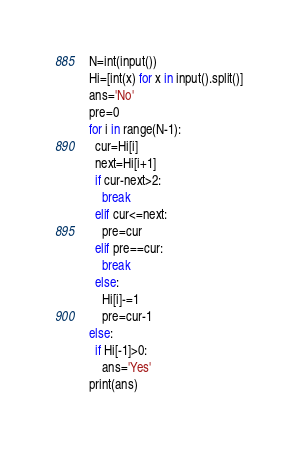Convert code to text. <code><loc_0><loc_0><loc_500><loc_500><_Python_>N=int(input())
Hi=[int(x) for x in input().split()]
ans='No'
pre=0
for i in range(N-1):
  cur=Hi[i]
  next=Hi[i+1]
  if cur-next>2:
    break
  elif cur<=next:
    pre=cur
  elif pre==cur:
    break
  else:
    Hi[i]-=1
    pre=cur-1
else:
  if Hi[-1]>0:
    ans='Yes'
print(ans)</code> 